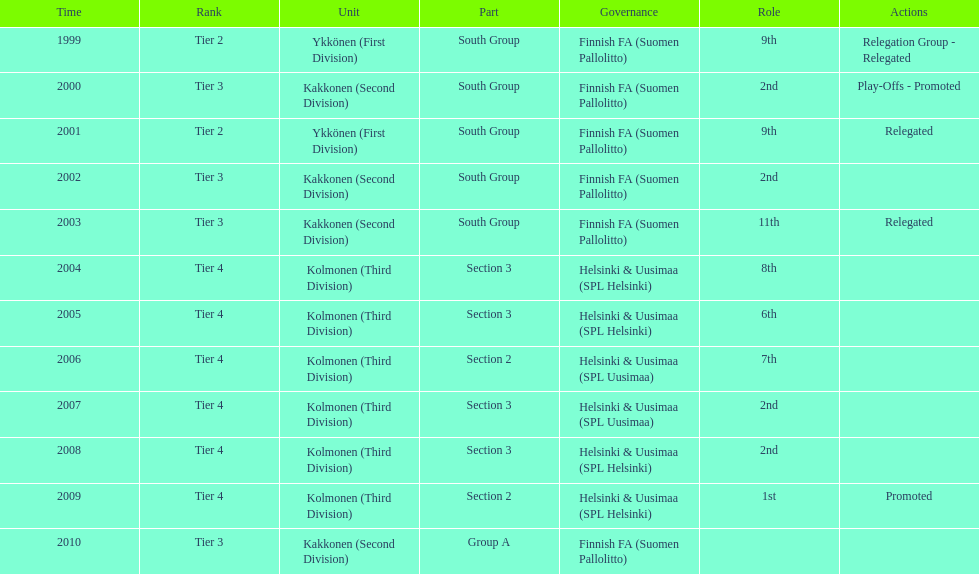How many consecutive times did they play in tier 4? 6. 